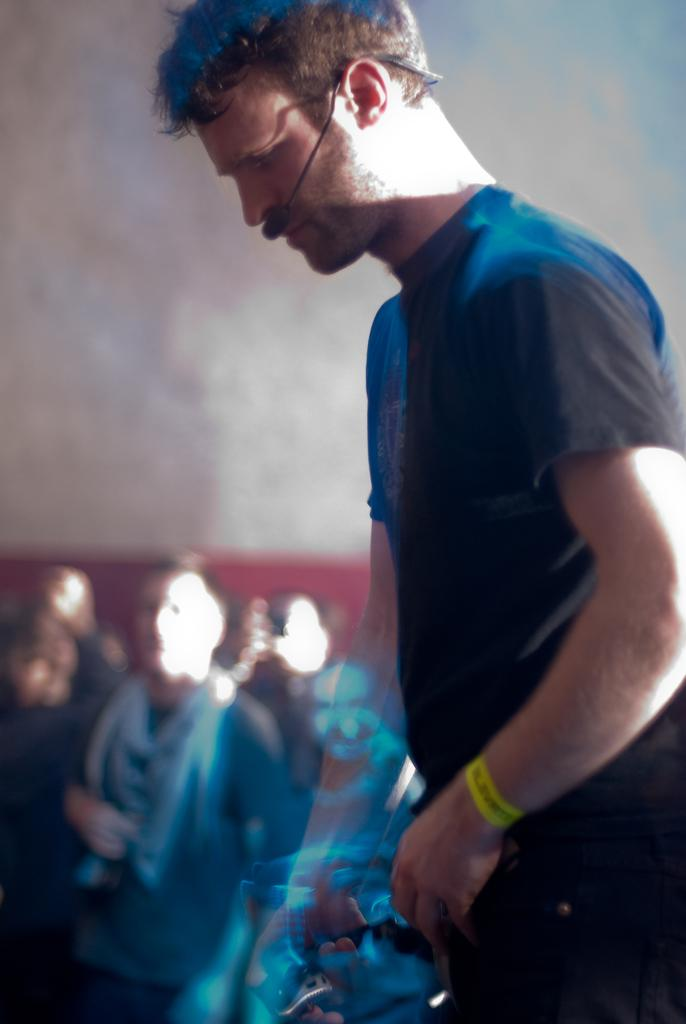What is the main subject of the image? There is a man standing in the image. Can you describe the surroundings of the man? There are persons in the background of the image, and there is a wall in the background as well. How many roses can be seen on the man's shirt in the image? There are no roses visible on the man's shirt in the image. What type of office furniture can be seen in the image? There is no office furniture present in the image. 